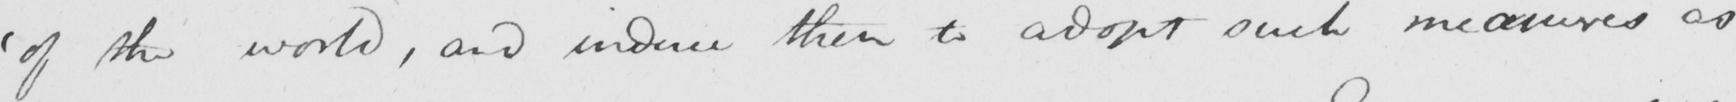What does this handwritten line say? ' of the world , and induce them to adopt such measures as 